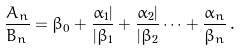Convert formula to latex. <formula><loc_0><loc_0><loc_500><loc_500>\frac { A _ { n } } { B _ { n } } = \beta _ { 0 } + \frac { \alpha _ { 1 } | } { | \beta _ { 1 } } + \frac { \alpha _ { 2 } | } { | \beta _ { 2 } } \dots + \frac { \alpha _ { n } } { \beta _ { n } } \, .</formula> 